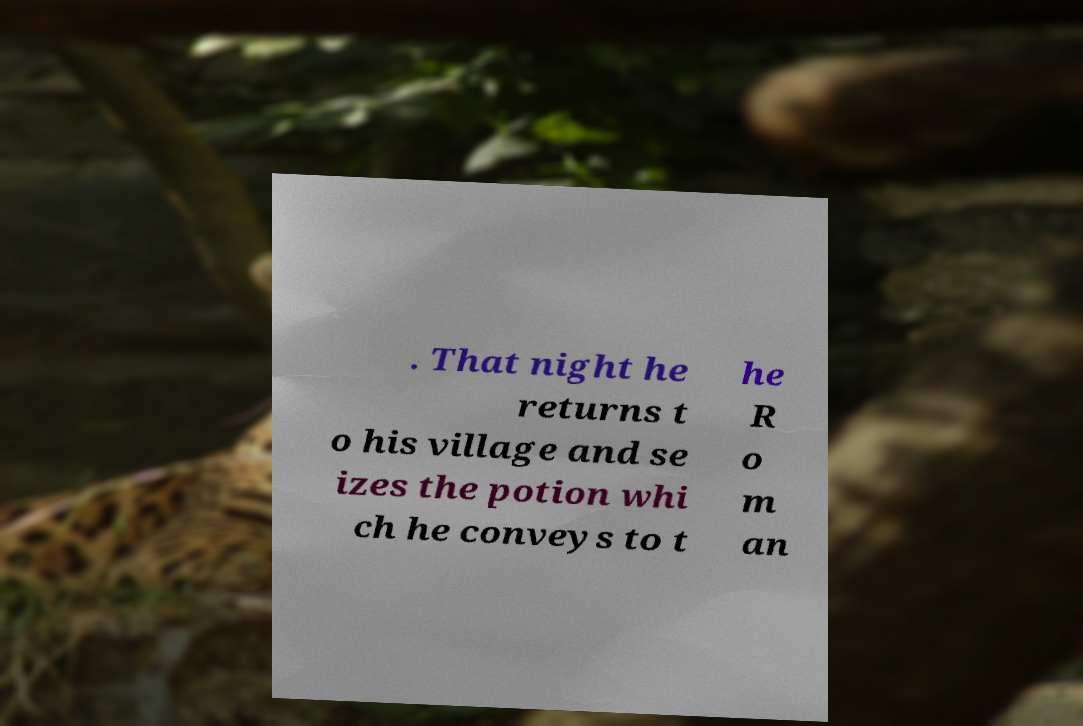For documentation purposes, I need the text within this image transcribed. Could you provide that? . That night he returns t o his village and se izes the potion whi ch he conveys to t he R o m an 